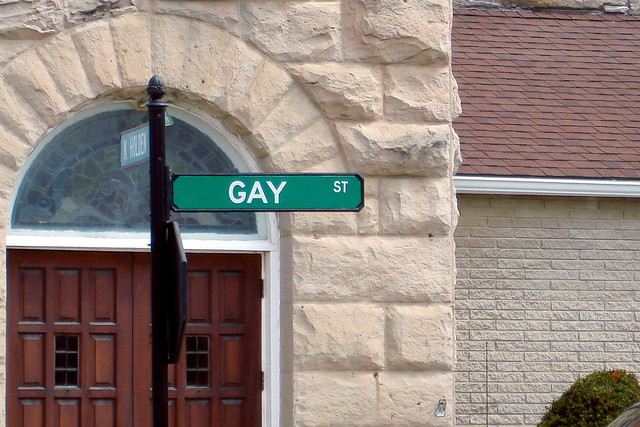Please transcribe the text in this image. GAY ST 